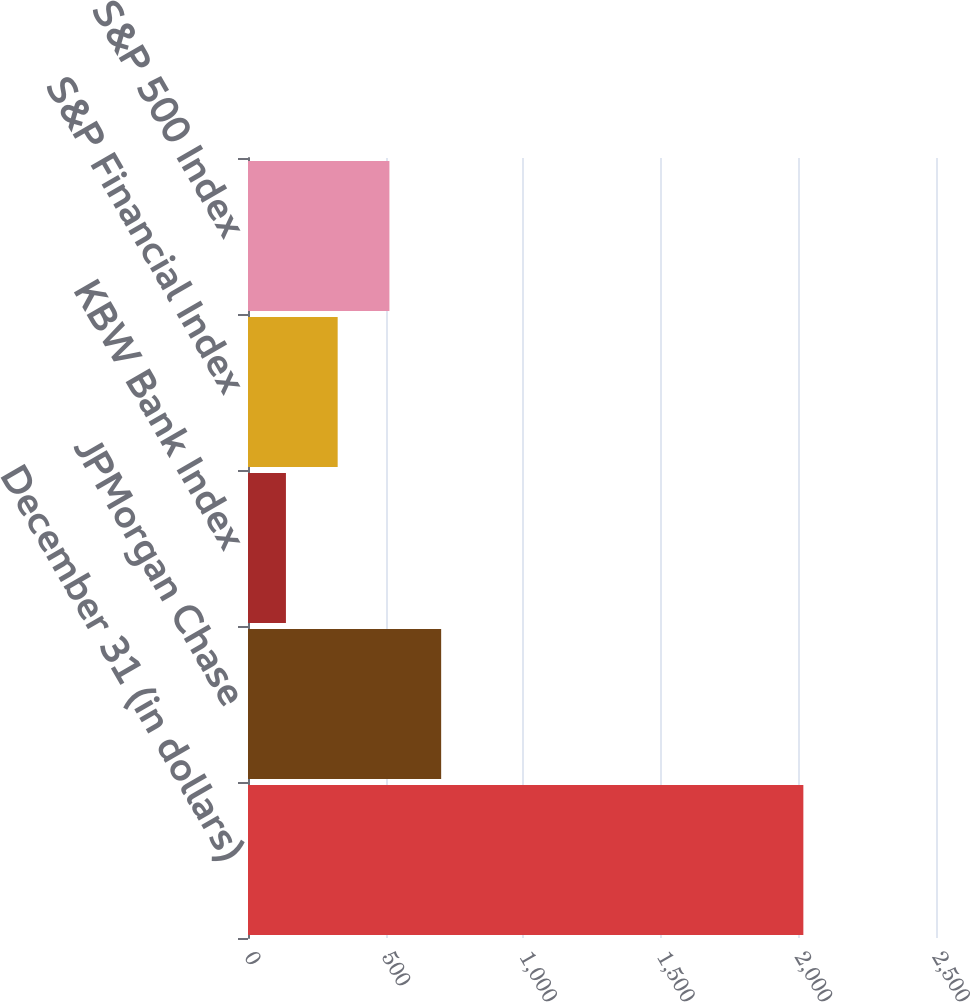Convert chart. <chart><loc_0><loc_0><loc_500><loc_500><bar_chart><fcel>December 31 (in dollars)<fcel>JPMorgan Chase<fcel>KBW Bank Index<fcel>S&P Financial Index<fcel>S&P 500 Index<nl><fcel>2018<fcel>701.88<fcel>137.82<fcel>325.84<fcel>513.86<nl></chart> 